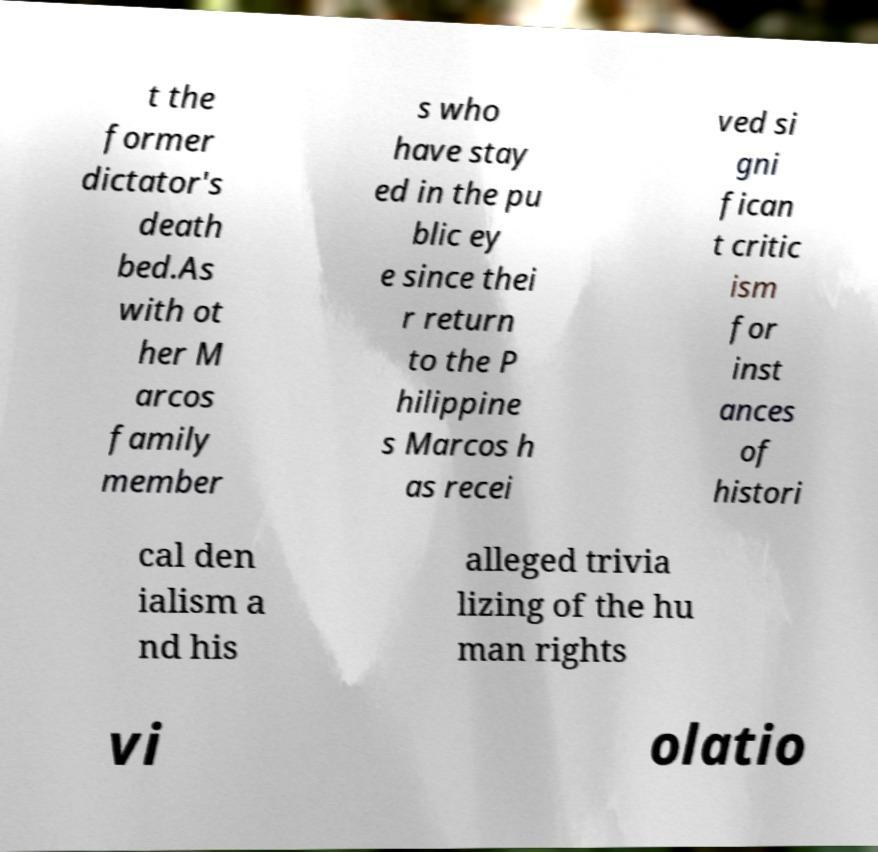Can you read and provide the text displayed in the image?This photo seems to have some interesting text. Can you extract and type it out for me? t the former dictator's death bed.As with ot her M arcos family member s who have stay ed in the pu blic ey e since thei r return to the P hilippine s Marcos h as recei ved si gni fican t critic ism for inst ances of histori cal den ialism a nd his alleged trivia lizing of the hu man rights vi olatio 